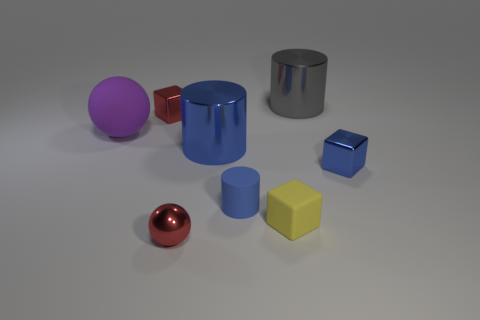What is the small blue cylinder made of?
Your answer should be very brief. Rubber. Is the size of the purple matte object the same as the gray cylinder?
Make the answer very short. Yes. How many cubes are either large purple objects or big red objects?
Give a very brief answer. 0. The tiny metal cube left of the large object that is to the right of the yellow matte cube is what color?
Your response must be concise. Red. Are there fewer balls that are right of the small yellow thing than big spheres left of the tiny red ball?
Keep it short and to the point. Yes. There is a yellow cube; is it the same size as the blue shiny thing on the right side of the small cylinder?
Give a very brief answer. Yes. The big object that is behind the big blue thing and on the left side of the tiny yellow block has what shape?
Offer a terse response. Sphere. There is a blue block that is made of the same material as the tiny red block; what size is it?
Ensure brevity in your answer.  Small. What number of blue cubes are behind the tiny shiny object to the left of the small red metal sphere?
Ensure brevity in your answer.  0. Is the large thing behind the big purple ball made of the same material as the small red sphere?
Offer a terse response. Yes. 